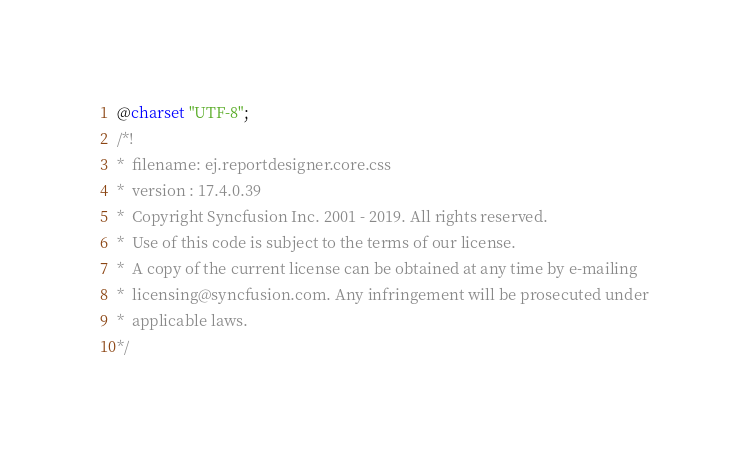<code> <loc_0><loc_0><loc_500><loc_500><_CSS_>@charset "UTF-8";
/*!
*  filename: ej.reportdesigner.core.css
*  version : 17.4.0.39
*  Copyright Syncfusion Inc. 2001 - 2019. All rights reserved.
*  Use of this code is subject to the terms of our license.
*  A copy of the current license can be obtained at any time by e-mailing
*  licensing@syncfusion.com. Any infringement will be prosecuted under
*  applicable laws.
*/
</code> 